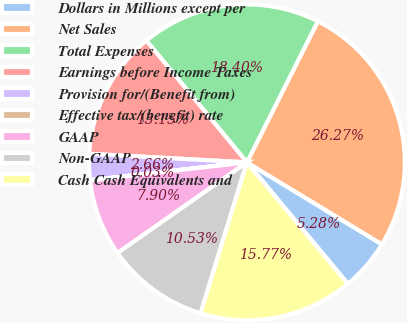<chart> <loc_0><loc_0><loc_500><loc_500><pie_chart><fcel>Dollars in Millions except per<fcel>Net Sales<fcel>Total Expenses<fcel>Earnings before Income Taxes<fcel>Provision for/(Benefit from)<fcel>Effective tax/(benefit) rate<fcel>GAAP<fcel>Non-GAAP<fcel>Cash Cash Equivalents and<nl><fcel>5.28%<fcel>26.27%<fcel>18.4%<fcel>13.15%<fcel>2.66%<fcel>0.03%<fcel>7.9%<fcel>10.53%<fcel>15.77%<nl></chart> 